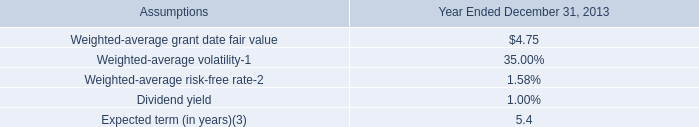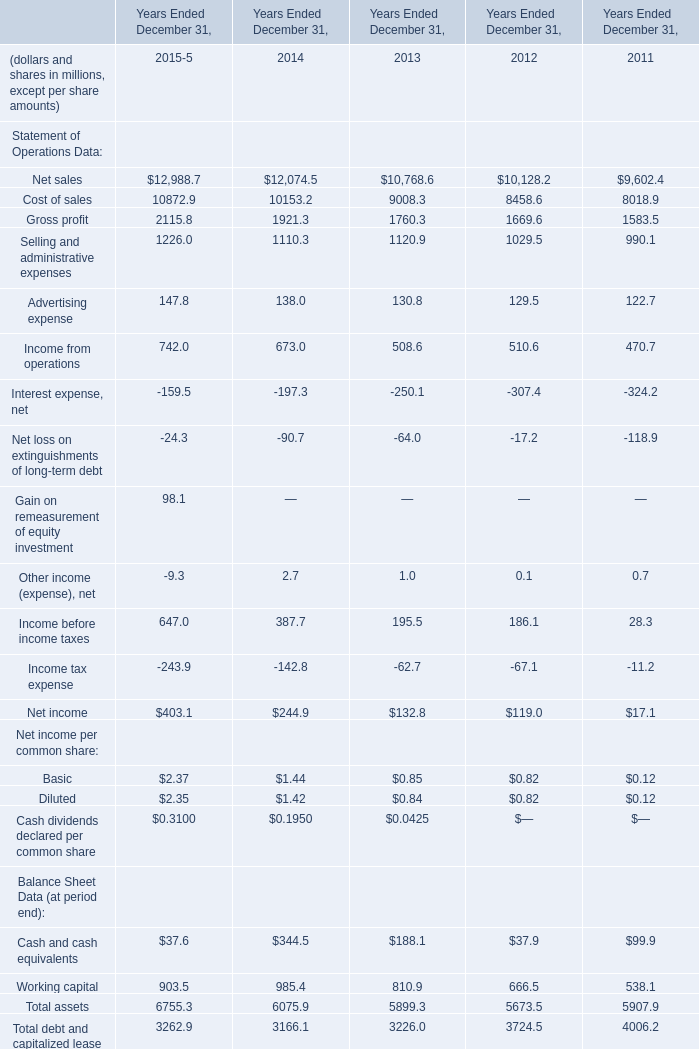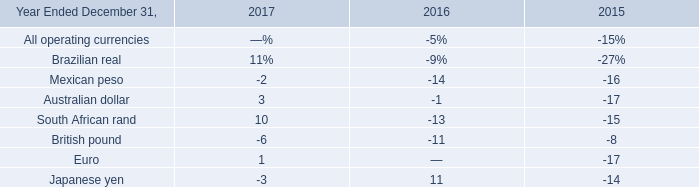What's the current growth rate of total assets? (in %) 
Computations: ((6755.3 - 6075.9) / 6075.9)
Answer: 0.11182. 